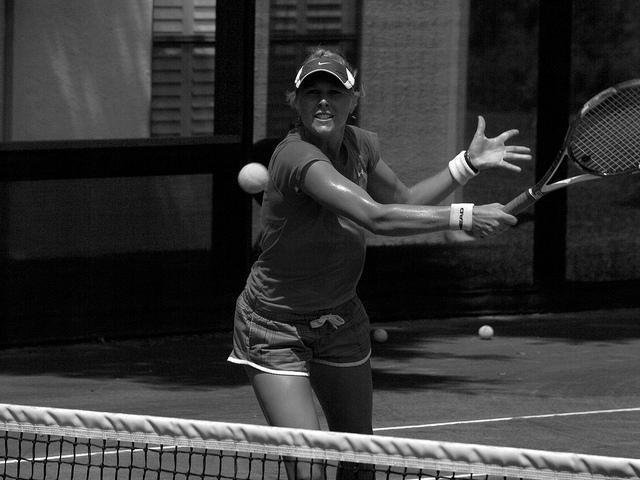How many baby elephants are there?
Give a very brief answer. 0. 